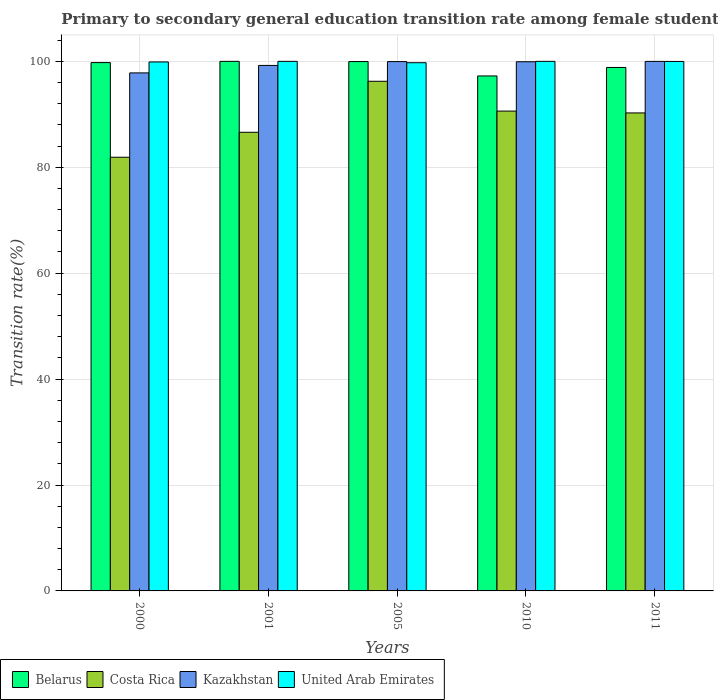How many different coloured bars are there?
Provide a short and direct response. 4. How many groups of bars are there?
Offer a very short reply. 5. Are the number of bars on each tick of the X-axis equal?
Offer a very short reply. Yes. How many bars are there on the 1st tick from the right?
Give a very brief answer. 4. In how many cases, is the number of bars for a given year not equal to the number of legend labels?
Offer a terse response. 0. What is the transition rate in United Arab Emirates in 2005?
Make the answer very short. 99.74. Across all years, what is the maximum transition rate in United Arab Emirates?
Give a very brief answer. 100. Across all years, what is the minimum transition rate in Costa Rica?
Your response must be concise. 81.89. In which year was the transition rate in United Arab Emirates minimum?
Give a very brief answer. 2005. What is the total transition rate in Kazakhstan in the graph?
Your response must be concise. 496.92. What is the difference between the transition rate in Belarus in 2001 and that in 2011?
Ensure brevity in your answer.  1.15. What is the difference between the transition rate in Belarus in 2011 and the transition rate in United Arab Emirates in 2010?
Your answer should be very brief. -1.15. What is the average transition rate in United Arab Emirates per year?
Keep it short and to the point. 99.92. In the year 2011, what is the difference between the transition rate in Costa Rica and transition rate in Kazakhstan?
Provide a short and direct response. -9.73. What is the ratio of the transition rate in Costa Rica in 2001 to that in 2010?
Make the answer very short. 0.96. What is the difference between the highest and the second highest transition rate in Kazakhstan?
Offer a terse response. 0.04. What is the difference between the highest and the lowest transition rate in Belarus?
Keep it short and to the point. 2.76. What does the 3rd bar from the left in 2005 represents?
Give a very brief answer. Kazakhstan. What does the 1st bar from the right in 2011 represents?
Ensure brevity in your answer.  United Arab Emirates. How many bars are there?
Offer a very short reply. 20. How many years are there in the graph?
Your response must be concise. 5. What is the difference between two consecutive major ticks on the Y-axis?
Provide a short and direct response. 20. Does the graph contain grids?
Ensure brevity in your answer.  Yes. Where does the legend appear in the graph?
Your answer should be very brief. Bottom left. How many legend labels are there?
Your answer should be very brief. 4. What is the title of the graph?
Ensure brevity in your answer.  Primary to secondary general education transition rate among female students. What is the label or title of the Y-axis?
Give a very brief answer. Transition rate(%). What is the Transition rate(%) in Belarus in 2000?
Give a very brief answer. 99.76. What is the Transition rate(%) of Costa Rica in 2000?
Give a very brief answer. 81.89. What is the Transition rate(%) in Kazakhstan in 2000?
Keep it short and to the point. 97.82. What is the Transition rate(%) in United Arab Emirates in 2000?
Provide a succinct answer. 99.89. What is the Transition rate(%) in Costa Rica in 2001?
Your answer should be compact. 86.61. What is the Transition rate(%) of Kazakhstan in 2001?
Your response must be concise. 99.23. What is the Transition rate(%) of United Arab Emirates in 2001?
Make the answer very short. 100. What is the Transition rate(%) of Belarus in 2005?
Ensure brevity in your answer.  99.96. What is the Transition rate(%) in Costa Rica in 2005?
Ensure brevity in your answer.  96.24. What is the Transition rate(%) of Kazakhstan in 2005?
Your answer should be compact. 99.95. What is the Transition rate(%) in United Arab Emirates in 2005?
Give a very brief answer. 99.74. What is the Transition rate(%) in Belarus in 2010?
Your answer should be very brief. 97.24. What is the Transition rate(%) in Costa Rica in 2010?
Provide a succinct answer. 90.61. What is the Transition rate(%) of Kazakhstan in 2010?
Provide a succinct answer. 99.93. What is the Transition rate(%) in United Arab Emirates in 2010?
Offer a terse response. 100. What is the Transition rate(%) of Belarus in 2011?
Your answer should be compact. 98.85. What is the Transition rate(%) of Costa Rica in 2011?
Your answer should be compact. 90.26. What is the Transition rate(%) of Kazakhstan in 2011?
Your answer should be very brief. 99.99. What is the Transition rate(%) of United Arab Emirates in 2011?
Make the answer very short. 99.98. Across all years, what is the maximum Transition rate(%) in Costa Rica?
Offer a terse response. 96.24. Across all years, what is the maximum Transition rate(%) in Kazakhstan?
Your answer should be compact. 99.99. Across all years, what is the maximum Transition rate(%) of United Arab Emirates?
Your response must be concise. 100. Across all years, what is the minimum Transition rate(%) of Belarus?
Offer a terse response. 97.24. Across all years, what is the minimum Transition rate(%) in Costa Rica?
Offer a terse response. 81.89. Across all years, what is the minimum Transition rate(%) in Kazakhstan?
Make the answer very short. 97.82. Across all years, what is the minimum Transition rate(%) of United Arab Emirates?
Ensure brevity in your answer.  99.74. What is the total Transition rate(%) of Belarus in the graph?
Your answer should be compact. 495.82. What is the total Transition rate(%) of Costa Rica in the graph?
Your answer should be very brief. 445.61. What is the total Transition rate(%) in Kazakhstan in the graph?
Make the answer very short. 496.92. What is the total Transition rate(%) in United Arab Emirates in the graph?
Offer a terse response. 499.61. What is the difference between the Transition rate(%) of Belarus in 2000 and that in 2001?
Keep it short and to the point. -0.24. What is the difference between the Transition rate(%) in Costa Rica in 2000 and that in 2001?
Give a very brief answer. -4.71. What is the difference between the Transition rate(%) in Kazakhstan in 2000 and that in 2001?
Offer a terse response. -1.41. What is the difference between the Transition rate(%) in United Arab Emirates in 2000 and that in 2001?
Your answer should be compact. -0.11. What is the difference between the Transition rate(%) of Belarus in 2000 and that in 2005?
Offer a terse response. -0.2. What is the difference between the Transition rate(%) in Costa Rica in 2000 and that in 2005?
Provide a short and direct response. -14.35. What is the difference between the Transition rate(%) of Kazakhstan in 2000 and that in 2005?
Ensure brevity in your answer.  -2.13. What is the difference between the Transition rate(%) of United Arab Emirates in 2000 and that in 2005?
Keep it short and to the point. 0.14. What is the difference between the Transition rate(%) of Belarus in 2000 and that in 2010?
Your response must be concise. 2.52. What is the difference between the Transition rate(%) in Costa Rica in 2000 and that in 2010?
Give a very brief answer. -8.72. What is the difference between the Transition rate(%) in Kazakhstan in 2000 and that in 2010?
Offer a very short reply. -2.11. What is the difference between the Transition rate(%) of United Arab Emirates in 2000 and that in 2010?
Offer a very short reply. -0.11. What is the difference between the Transition rate(%) in Belarus in 2000 and that in 2011?
Provide a short and direct response. 0.92. What is the difference between the Transition rate(%) in Costa Rica in 2000 and that in 2011?
Provide a succinct answer. -8.37. What is the difference between the Transition rate(%) of Kazakhstan in 2000 and that in 2011?
Keep it short and to the point. -2.17. What is the difference between the Transition rate(%) of United Arab Emirates in 2000 and that in 2011?
Offer a very short reply. -0.09. What is the difference between the Transition rate(%) of Belarus in 2001 and that in 2005?
Make the answer very short. 0.04. What is the difference between the Transition rate(%) in Costa Rica in 2001 and that in 2005?
Your response must be concise. -9.63. What is the difference between the Transition rate(%) in Kazakhstan in 2001 and that in 2005?
Keep it short and to the point. -0.72. What is the difference between the Transition rate(%) of United Arab Emirates in 2001 and that in 2005?
Offer a terse response. 0.26. What is the difference between the Transition rate(%) of Belarus in 2001 and that in 2010?
Keep it short and to the point. 2.75. What is the difference between the Transition rate(%) in Costa Rica in 2001 and that in 2010?
Offer a very short reply. -4. What is the difference between the Transition rate(%) in Kazakhstan in 2001 and that in 2010?
Give a very brief answer. -0.7. What is the difference between the Transition rate(%) in United Arab Emirates in 2001 and that in 2010?
Ensure brevity in your answer.  0. What is the difference between the Transition rate(%) of Belarus in 2001 and that in 2011?
Give a very brief answer. 1.15. What is the difference between the Transition rate(%) in Costa Rica in 2001 and that in 2011?
Give a very brief answer. -3.66. What is the difference between the Transition rate(%) in Kazakhstan in 2001 and that in 2011?
Offer a very short reply. -0.76. What is the difference between the Transition rate(%) of United Arab Emirates in 2001 and that in 2011?
Provide a succinct answer. 0.02. What is the difference between the Transition rate(%) of Belarus in 2005 and that in 2010?
Ensure brevity in your answer.  2.72. What is the difference between the Transition rate(%) of Costa Rica in 2005 and that in 2010?
Provide a succinct answer. 5.63. What is the difference between the Transition rate(%) in Kazakhstan in 2005 and that in 2010?
Your response must be concise. 0.03. What is the difference between the Transition rate(%) in United Arab Emirates in 2005 and that in 2010?
Give a very brief answer. -0.26. What is the difference between the Transition rate(%) of Belarus in 2005 and that in 2011?
Your answer should be compact. 1.11. What is the difference between the Transition rate(%) in Costa Rica in 2005 and that in 2011?
Offer a very short reply. 5.98. What is the difference between the Transition rate(%) of Kazakhstan in 2005 and that in 2011?
Offer a very short reply. -0.04. What is the difference between the Transition rate(%) of United Arab Emirates in 2005 and that in 2011?
Provide a short and direct response. -0.24. What is the difference between the Transition rate(%) of Belarus in 2010 and that in 2011?
Keep it short and to the point. -1.6. What is the difference between the Transition rate(%) in Costa Rica in 2010 and that in 2011?
Provide a succinct answer. 0.35. What is the difference between the Transition rate(%) of Kazakhstan in 2010 and that in 2011?
Your response must be concise. -0.07. What is the difference between the Transition rate(%) of United Arab Emirates in 2010 and that in 2011?
Make the answer very short. 0.02. What is the difference between the Transition rate(%) in Belarus in 2000 and the Transition rate(%) in Costa Rica in 2001?
Keep it short and to the point. 13.16. What is the difference between the Transition rate(%) in Belarus in 2000 and the Transition rate(%) in Kazakhstan in 2001?
Provide a succinct answer. 0.53. What is the difference between the Transition rate(%) of Belarus in 2000 and the Transition rate(%) of United Arab Emirates in 2001?
Provide a short and direct response. -0.24. What is the difference between the Transition rate(%) in Costa Rica in 2000 and the Transition rate(%) in Kazakhstan in 2001?
Your answer should be compact. -17.34. What is the difference between the Transition rate(%) of Costa Rica in 2000 and the Transition rate(%) of United Arab Emirates in 2001?
Offer a very short reply. -18.11. What is the difference between the Transition rate(%) of Kazakhstan in 2000 and the Transition rate(%) of United Arab Emirates in 2001?
Ensure brevity in your answer.  -2.18. What is the difference between the Transition rate(%) in Belarus in 2000 and the Transition rate(%) in Costa Rica in 2005?
Your answer should be compact. 3.52. What is the difference between the Transition rate(%) in Belarus in 2000 and the Transition rate(%) in Kazakhstan in 2005?
Offer a terse response. -0.19. What is the difference between the Transition rate(%) in Belarus in 2000 and the Transition rate(%) in United Arab Emirates in 2005?
Keep it short and to the point. 0.02. What is the difference between the Transition rate(%) in Costa Rica in 2000 and the Transition rate(%) in Kazakhstan in 2005?
Offer a very short reply. -18.06. What is the difference between the Transition rate(%) in Costa Rica in 2000 and the Transition rate(%) in United Arab Emirates in 2005?
Your response must be concise. -17.85. What is the difference between the Transition rate(%) in Kazakhstan in 2000 and the Transition rate(%) in United Arab Emirates in 2005?
Offer a terse response. -1.92. What is the difference between the Transition rate(%) in Belarus in 2000 and the Transition rate(%) in Costa Rica in 2010?
Provide a short and direct response. 9.16. What is the difference between the Transition rate(%) of Belarus in 2000 and the Transition rate(%) of Kazakhstan in 2010?
Provide a succinct answer. -0.16. What is the difference between the Transition rate(%) in Belarus in 2000 and the Transition rate(%) in United Arab Emirates in 2010?
Give a very brief answer. -0.24. What is the difference between the Transition rate(%) in Costa Rica in 2000 and the Transition rate(%) in Kazakhstan in 2010?
Provide a succinct answer. -18.03. What is the difference between the Transition rate(%) in Costa Rica in 2000 and the Transition rate(%) in United Arab Emirates in 2010?
Ensure brevity in your answer.  -18.11. What is the difference between the Transition rate(%) of Kazakhstan in 2000 and the Transition rate(%) of United Arab Emirates in 2010?
Give a very brief answer. -2.18. What is the difference between the Transition rate(%) of Belarus in 2000 and the Transition rate(%) of Costa Rica in 2011?
Keep it short and to the point. 9.5. What is the difference between the Transition rate(%) of Belarus in 2000 and the Transition rate(%) of Kazakhstan in 2011?
Ensure brevity in your answer.  -0.23. What is the difference between the Transition rate(%) of Belarus in 2000 and the Transition rate(%) of United Arab Emirates in 2011?
Ensure brevity in your answer.  -0.22. What is the difference between the Transition rate(%) in Costa Rica in 2000 and the Transition rate(%) in Kazakhstan in 2011?
Keep it short and to the point. -18.1. What is the difference between the Transition rate(%) in Costa Rica in 2000 and the Transition rate(%) in United Arab Emirates in 2011?
Offer a terse response. -18.09. What is the difference between the Transition rate(%) of Kazakhstan in 2000 and the Transition rate(%) of United Arab Emirates in 2011?
Ensure brevity in your answer.  -2.16. What is the difference between the Transition rate(%) in Belarus in 2001 and the Transition rate(%) in Costa Rica in 2005?
Provide a short and direct response. 3.76. What is the difference between the Transition rate(%) of Belarus in 2001 and the Transition rate(%) of Kazakhstan in 2005?
Your answer should be compact. 0.05. What is the difference between the Transition rate(%) of Belarus in 2001 and the Transition rate(%) of United Arab Emirates in 2005?
Give a very brief answer. 0.26. What is the difference between the Transition rate(%) of Costa Rica in 2001 and the Transition rate(%) of Kazakhstan in 2005?
Make the answer very short. -13.35. What is the difference between the Transition rate(%) in Costa Rica in 2001 and the Transition rate(%) in United Arab Emirates in 2005?
Give a very brief answer. -13.14. What is the difference between the Transition rate(%) of Kazakhstan in 2001 and the Transition rate(%) of United Arab Emirates in 2005?
Provide a succinct answer. -0.51. What is the difference between the Transition rate(%) of Belarus in 2001 and the Transition rate(%) of Costa Rica in 2010?
Offer a terse response. 9.39. What is the difference between the Transition rate(%) in Belarus in 2001 and the Transition rate(%) in Kazakhstan in 2010?
Provide a succinct answer. 0.07. What is the difference between the Transition rate(%) of Belarus in 2001 and the Transition rate(%) of United Arab Emirates in 2010?
Keep it short and to the point. 0. What is the difference between the Transition rate(%) of Costa Rica in 2001 and the Transition rate(%) of Kazakhstan in 2010?
Keep it short and to the point. -13.32. What is the difference between the Transition rate(%) in Costa Rica in 2001 and the Transition rate(%) in United Arab Emirates in 2010?
Your answer should be very brief. -13.39. What is the difference between the Transition rate(%) in Kazakhstan in 2001 and the Transition rate(%) in United Arab Emirates in 2010?
Your answer should be compact. -0.77. What is the difference between the Transition rate(%) in Belarus in 2001 and the Transition rate(%) in Costa Rica in 2011?
Make the answer very short. 9.74. What is the difference between the Transition rate(%) of Belarus in 2001 and the Transition rate(%) of Kazakhstan in 2011?
Keep it short and to the point. 0.01. What is the difference between the Transition rate(%) in Belarus in 2001 and the Transition rate(%) in United Arab Emirates in 2011?
Your answer should be compact. 0.02. What is the difference between the Transition rate(%) of Costa Rica in 2001 and the Transition rate(%) of Kazakhstan in 2011?
Your answer should be very brief. -13.39. What is the difference between the Transition rate(%) in Costa Rica in 2001 and the Transition rate(%) in United Arab Emirates in 2011?
Offer a very short reply. -13.38. What is the difference between the Transition rate(%) of Kazakhstan in 2001 and the Transition rate(%) of United Arab Emirates in 2011?
Offer a very short reply. -0.75. What is the difference between the Transition rate(%) of Belarus in 2005 and the Transition rate(%) of Costa Rica in 2010?
Make the answer very short. 9.35. What is the difference between the Transition rate(%) in Belarus in 2005 and the Transition rate(%) in Kazakhstan in 2010?
Your response must be concise. 0.04. What is the difference between the Transition rate(%) in Belarus in 2005 and the Transition rate(%) in United Arab Emirates in 2010?
Your answer should be very brief. -0.04. What is the difference between the Transition rate(%) of Costa Rica in 2005 and the Transition rate(%) of Kazakhstan in 2010?
Offer a very short reply. -3.69. What is the difference between the Transition rate(%) in Costa Rica in 2005 and the Transition rate(%) in United Arab Emirates in 2010?
Give a very brief answer. -3.76. What is the difference between the Transition rate(%) in Kazakhstan in 2005 and the Transition rate(%) in United Arab Emirates in 2010?
Give a very brief answer. -0.05. What is the difference between the Transition rate(%) in Belarus in 2005 and the Transition rate(%) in Costa Rica in 2011?
Offer a very short reply. 9.7. What is the difference between the Transition rate(%) in Belarus in 2005 and the Transition rate(%) in Kazakhstan in 2011?
Provide a short and direct response. -0.03. What is the difference between the Transition rate(%) of Belarus in 2005 and the Transition rate(%) of United Arab Emirates in 2011?
Your answer should be compact. -0.02. What is the difference between the Transition rate(%) in Costa Rica in 2005 and the Transition rate(%) in Kazakhstan in 2011?
Keep it short and to the point. -3.75. What is the difference between the Transition rate(%) in Costa Rica in 2005 and the Transition rate(%) in United Arab Emirates in 2011?
Keep it short and to the point. -3.74. What is the difference between the Transition rate(%) of Kazakhstan in 2005 and the Transition rate(%) of United Arab Emirates in 2011?
Provide a succinct answer. -0.03. What is the difference between the Transition rate(%) in Belarus in 2010 and the Transition rate(%) in Costa Rica in 2011?
Your answer should be very brief. 6.98. What is the difference between the Transition rate(%) of Belarus in 2010 and the Transition rate(%) of Kazakhstan in 2011?
Offer a terse response. -2.75. What is the difference between the Transition rate(%) in Belarus in 2010 and the Transition rate(%) in United Arab Emirates in 2011?
Your response must be concise. -2.74. What is the difference between the Transition rate(%) of Costa Rica in 2010 and the Transition rate(%) of Kazakhstan in 2011?
Ensure brevity in your answer.  -9.38. What is the difference between the Transition rate(%) of Costa Rica in 2010 and the Transition rate(%) of United Arab Emirates in 2011?
Your answer should be very brief. -9.37. What is the difference between the Transition rate(%) in Kazakhstan in 2010 and the Transition rate(%) in United Arab Emirates in 2011?
Make the answer very short. -0.06. What is the average Transition rate(%) in Belarus per year?
Make the answer very short. 99.16. What is the average Transition rate(%) of Costa Rica per year?
Give a very brief answer. 89.12. What is the average Transition rate(%) in Kazakhstan per year?
Provide a short and direct response. 99.38. What is the average Transition rate(%) in United Arab Emirates per year?
Give a very brief answer. 99.92. In the year 2000, what is the difference between the Transition rate(%) of Belarus and Transition rate(%) of Costa Rica?
Your answer should be compact. 17.87. In the year 2000, what is the difference between the Transition rate(%) of Belarus and Transition rate(%) of Kazakhstan?
Provide a succinct answer. 1.94. In the year 2000, what is the difference between the Transition rate(%) of Belarus and Transition rate(%) of United Arab Emirates?
Your answer should be very brief. -0.12. In the year 2000, what is the difference between the Transition rate(%) of Costa Rica and Transition rate(%) of Kazakhstan?
Keep it short and to the point. -15.93. In the year 2000, what is the difference between the Transition rate(%) in Costa Rica and Transition rate(%) in United Arab Emirates?
Offer a terse response. -18. In the year 2000, what is the difference between the Transition rate(%) of Kazakhstan and Transition rate(%) of United Arab Emirates?
Give a very brief answer. -2.07. In the year 2001, what is the difference between the Transition rate(%) of Belarus and Transition rate(%) of Costa Rica?
Your response must be concise. 13.39. In the year 2001, what is the difference between the Transition rate(%) of Belarus and Transition rate(%) of Kazakhstan?
Offer a very short reply. 0.77. In the year 2001, what is the difference between the Transition rate(%) of Belarus and Transition rate(%) of United Arab Emirates?
Provide a short and direct response. 0. In the year 2001, what is the difference between the Transition rate(%) in Costa Rica and Transition rate(%) in Kazakhstan?
Ensure brevity in your answer.  -12.62. In the year 2001, what is the difference between the Transition rate(%) of Costa Rica and Transition rate(%) of United Arab Emirates?
Your response must be concise. -13.39. In the year 2001, what is the difference between the Transition rate(%) of Kazakhstan and Transition rate(%) of United Arab Emirates?
Your response must be concise. -0.77. In the year 2005, what is the difference between the Transition rate(%) of Belarus and Transition rate(%) of Costa Rica?
Provide a succinct answer. 3.72. In the year 2005, what is the difference between the Transition rate(%) in Belarus and Transition rate(%) in Kazakhstan?
Keep it short and to the point. 0.01. In the year 2005, what is the difference between the Transition rate(%) of Belarus and Transition rate(%) of United Arab Emirates?
Make the answer very short. 0.22. In the year 2005, what is the difference between the Transition rate(%) of Costa Rica and Transition rate(%) of Kazakhstan?
Offer a terse response. -3.71. In the year 2005, what is the difference between the Transition rate(%) in Costa Rica and Transition rate(%) in United Arab Emirates?
Give a very brief answer. -3.5. In the year 2005, what is the difference between the Transition rate(%) in Kazakhstan and Transition rate(%) in United Arab Emirates?
Your answer should be compact. 0.21. In the year 2010, what is the difference between the Transition rate(%) in Belarus and Transition rate(%) in Costa Rica?
Your answer should be compact. 6.64. In the year 2010, what is the difference between the Transition rate(%) in Belarus and Transition rate(%) in Kazakhstan?
Make the answer very short. -2.68. In the year 2010, what is the difference between the Transition rate(%) in Belarus and Transition rate(%) in United Arab Emirates?
Your answer should be very brief. -2.75. In the year 2010, what is the difference between the Transition rate(%) of Costa Rica and Transition rate(%) of Kazakhstan?
Offer a terse response. -9.32. In the year 2010, what is the difference between the Transition rate(%) of Costa Rica and Transition rate(%) of United Arab Emirates?
Make the answer very short. -9.39. In the year 2010, what is the difference between the Transition rate(%) in Kazakhstan and Transition rate(%) in United Arab Emirates?
Your answer should be compact. -0.07. In the year 2011, what is the difference between the Transition rate(%) in Belarus and Transition rate(%) in Costa Rica?
Provide a succinct answer. 8.59. In the year 2011, what is the difference between the Transition rate(%) in Belarus and Transition rate(%) in Kazakhstan?
Give a very brief answer. -1.15. In the year 2011, what is the difference between the Transition rate(%) of Belarus and Transition rate(%) of United Arab Emirates?
Your answer should be very brief. -1.14. In the year 2011, what is the difference between the Transition rate(%) of Costa Rica and Transition rate(%) of Kazakhstan?
Keep it short and to the point. -9.73. In the year 2011, what is the difference between the Transition rate(%) of Costa Rica and Transition rate(%) of United Arab Emirates?
Give a very brief answer. -9.72. In the year 2011, what is the difference between the Transition rate(%) in Kazakhstan and Transition rate(%) in United Arab Emirates?
Provide a succinct answer. 0.01. What is the ratio of the Transition rate(%) of Costa Rica in 2000 to that in 2001?
Your response must be concise. 0.95. What is the ratio of the Transition rate(%) of Kazakhstan in 2000 to that in 2001?
Your answer should be compact. 0.99. What is the ratio of the Transition rate(%) of United Arab Emirates in 2000 to that in 2001?
Make the answer very short. 1. What is the ratio of the Transition rate(%) in Costa Rica in 2000 to that in 2005?
Offer a terse response. 0.85. What is the ratio of the Transition rate(%) in Kazakhstan in 2000 to that in 2005?
Keep it short and to the point. 0.98. What is the ratio of the Transition rate(%) in Belarus in 2000 to that in 2010?
Your answer should be very brief. 1.03. What is the ratio of the Transition rate(%) in Costa Rica in 2000 to that in 2010?
Offer a very short reply. 0.9. What is the ratio of the Transition rate(%) of Kazakhstan in 2000 to that in 2010?
Provide a succinct answer. 0.98. What is the ratio of the Transition rate(%) in Belarus in 2000 to that in 2011?
Your answer should be very brief. 1.01. What is the ratio of the Transition rate(%) of Costa Rica in 2000 to that in 2011?
Offer a terse response. 0.91. What is the ratio of the Transition rate(%) in Kazakhstan in 2000 to that in 2011?
Your answer should be compact. 0.98. What is the ratio of the Transition rate(%) in Costa Rica in 2001 to that in 2005?
Make the answer very short. 0.9. What is the ratio of the Transition rate(%) of United Arab Emirates in 2001 to that in 2005?
Your answer should be very brief. 1. What is the ratio of the Transition rate(%) in Belarus in 2001 to that in 2010?
Provide a short and direct response. 1.03. What is the ratio of the Transition rate(%) in Costa Rica in 2001 to that in 2010?
Offer a very short reply. 0.96. What is the ratio of the Transition rate(%) of Kazakhstan in 2001 to that in 2010?
Ensure brevity in your answer.  0.99. What is the ratio of the Transition rate(%) in United Arab Emirates in 2001 to that in 2010?
Provide a succinct answer. 1. What is the ratio of the Transition rate(%) of Belarus in 2001 to that in 2011?
Keep it short and to the point. 1.01. What is the ratio of the Transition rate(%) in Costa Rica in 2001 to that in 2011?
Ensure brevity in your answer.  0.96. What is the ratio of the Transition rate(%) of United Arab Emirates in 2001 to that in 2011?
Keep it short and to the point. 1. What is the ratio of the Transition rate(%) of Belarus in 2005 to that in 2010?
Offer a terse response. 1.03. What is the ratio of the Transition rate(%) in Costa Rica in 2005 to that in 2010?
Offer a very short reply. 1.06. What is the ratio of the Transition rate(%) of United Arab Emirates in 2005 to that in 2010?
Offer a very short reply. 1. What is the ratio of the Transition rate(%) in Belarus in 2005 to that in 2011?
Keep it short and to the point. 1.01. What is the ratio of the Transition rate(%) of Costa Rica in 2005 to that in 2011?
Your response must be concise. 1.07. What is the ratio of the Transition rate(%) of Belarus in 2010 to that in 2011?
Provide a short and direct response. 0.98. What is the ratio of the Transition rate(%) of Kazakhstan in 2010 to that in 2011?
Your answer should be compact. 1. What is the ratio of the Transition rate(%) of United Arab Emirates in 2010 to that in 2011?
Give a very brief answer. 1. What is the difference between the highest and the second highest Transition rate(%) in Belarus?
Your answer should be very brief. 0.04. What is the difference between the highest and the second highest Transition rate(%) in Costa Rica?
Give a very brief answer. 5.63. What is the difference between the highest and the second highest Transition rate(%) in Kazakhstan?
Make the answer very short. 0.04. What is the difference between the highest and the second highest Transition rate(%) of United Arab Emirates?
Your answer should be compact. 0. What is the difference between the highest and the lowest Transition rate(%) of Belarus?
Give a very brief answer. 2.75. What is the difference between the highest and the lowest Transition rate(%) in Costa Rica?
Make the answer very short. 14.35. What is the difference between the highest and the lowest Transition rate(%) of Kazakhstan?
Keep it short and to the point. 2.17. What is the difference between the highest and the lowest Transition rate(%) of United Arab Emirates?
Ensure brevity in your answer.  0.26. 